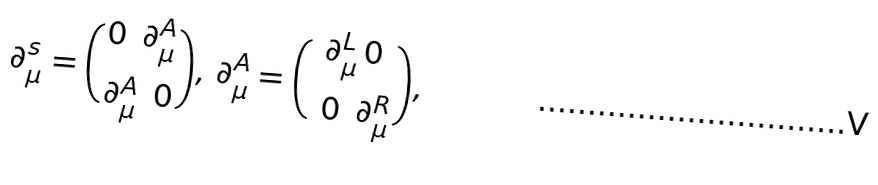Convert formula to latex. <formula><loc_0><loc_0><loc_500><loc_500>\partial _ { \mu } ^ { s } = { { 0 \ \, \partial _ { \mu } ^ { A } } \choose { \partial _ { \mu } ^ { A } \, \ 0 } } , \, \partial _ { \mu } ^ { A } = { { \partial _ { \mu } ^ { L } \, 0 } \choose { \ 0 \, \ \partial _ { \mu } ^ { R } } } ,</formula> 